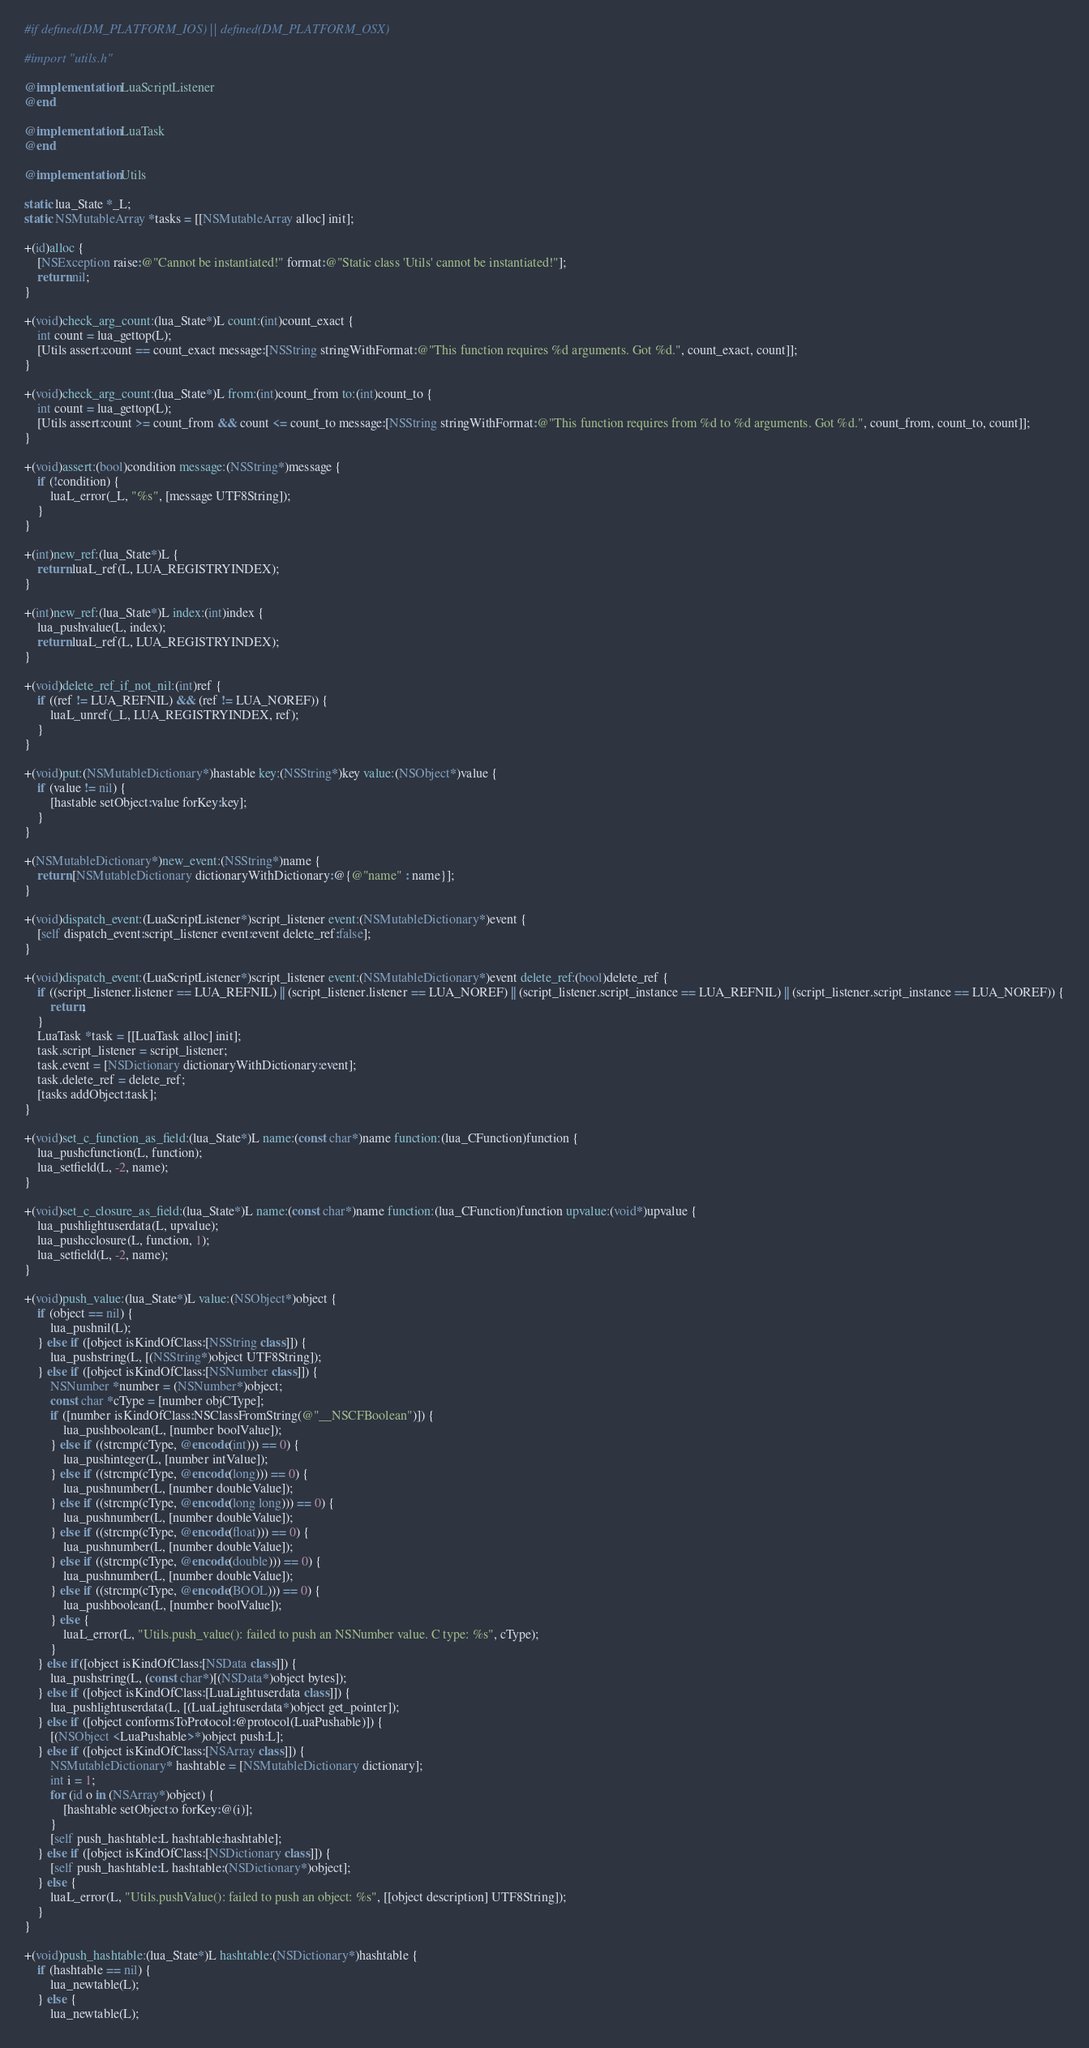<code> <loc_0><loc_0><loc_500><loc_500><_ObjectiveC_>#if defined(DM_PLATFORM_IOS) || defined(DM_PLATFORM_OSX)

#import "utils.h"

@implementation LuaScriptListener
@end

@implementation LuaTask
@end

@implementation Utils

static lua_State *_L;
static NSMutableArray *tasks = [[NSMutableArray alloc] init];

+(id)alloc {
	[NSException raise:@"Cannot be instantiated!" format:@"Static class 'Utils' cannot be instantiated!"];
	return nil;
}

+(void)check_arg_count:(lua_State*)L count:(int)count_exact {
	int count = lua_gettop(L);
	[Utils assert:count == count_exact message:[NSString stringWithFormat:@"This function requires %d arguments. Got %d.", count_exact, count]];
}

+(void)check_arg_count:(lua_State*)L from:(int)count_from to:(int)count_to {
	int count = lua_gettop(L);
	[Utils assert:count >= count_from && count <= count_to message:[NSString stringWithFormat:@"This function requires from %d to %d arguments. Got %d.", count_from, count_to, count]];
}

+(void)assert:(bool)condition message:(NSString*)message {
	if (!condition) {
		luaL_error(_L, "%s", [message UTF8String]);
	}
}

+(int)new_ref:(lua_State*)L {
	return luaL_ref(L, LUA_REGISTRYINDEX);
}

+(int)new_ref:(lua_State*)L index:(int)index {
	lua_pushvalue(L, index);
	return luaL_ref(L, LUA_REGISTRYINDEX);
}

+(void)delete_ref_if_not_nil:(int)ref {
	if ((ref != LUA_REFNIL) && (ref != LUA_NOREF)) {
		luaL_unref(_L, LUA_REGISTRYINDEX, ref);
	}
}

+(void)put:(NSMutableDictionary*)hastable key:(NSString*)key value:(NSObject*)value {
	if (value != nil) {
		[hastable setObject:value forKey:key];
	}
}

+(NSMutableDictionary*)new_event:(NSString*)name {
	return [NSMutableDictionary dictionaryWithDictionary:@{@"name" : name}];
}

+(void)dispatch_event:(LuaScriptListener*)script_listener event:(NSMutableDictionary*)event {
	[self dispatch_event:script_listener event:event delete_ref:false];
}

+(void)dispatch_event:(LuaScriptListener*)script_listener event:(NSMutableDictionary*)event delete_ref:(bool)delete_ref {
	if ((script_listener.listener == LUA_REFNIL) || (script_listener.listener == LUA_NOREF) || (script_listener.script_instance == LUA_REFNIL) || (script_listener.script_instance == LUA_NOREF)) {
		return;
	}
	LuaTask *task = [[LuaTask alloc] init];
	task.script_listener = script_listener;
	task.event = [NSDictionary dictionaryWithDictionary:event];
	task.delete_ref = delete_ref;
	[tasks addObject:task];
}

+(void)set_c_function_as_field:(lua_State*)L name:(const char*)name function:(lua_CFunction)function {
	lua_pushcfunction(L, function);
	lua_setfield(L, -2, name);
}

+(void)set_c_closure_as_field:(lua_State*)L name:(const char*)name function:(lua_CFunction)function upvalue:(void*)upvalue {
	lua_pushlightuserdata(L, upvalue);
	lua_pushcclosure(L, function, 1);
	lua_setfield(L, -2, name);
}

+(void)push_value:(lua_State*)L value:(NSObject*)object {
	if (object == nil) {
		lua_pushnil(L);
	} else if ([object isKindOfClass:[NSString class]]) {
		lua_pushstring(L, [(NSString*)object UTF8String]);
	} else if ([object isKindOfClass:[NSNumber class]]) {
		NSNumber *number = (NSNumber*)object;
		const char *cType = [number objCType];
		if ([number isKindOfClass:NSClassFromString(@"__NSCFBoolean")]) {
			lua_pushboolean(L, [number boolValue]);
		} else if ((strcmp(cType, @encode(int))) == 0) {
			lua_pushinteger(L, [number intValue]);
		} else if ((strcmp(cType, @encode(long))) == 0) {
			lua_pushnumber(L, [number doubleValue]);
		} else if ((strcmp(cType, @encode(long long))) == 0) {
			lua_pushnumber(L, [number doubleValue]);
		} else if ((strcmp(cType, @encode(float))) == 0) {
			lua_pushnumber(L, [number doubleValue]);
		} else if ((strcmp(cType, @encode(double))) == 0) {
			lua_pushnumber(L, [number doubleValue]);
		} else if ((strcmp(cType, @encode(BOOL))) == 0) {
			lua_pushboolean(L, [number boolValue]);
		} else {
			luaL_error(L, "Utils.push_value(): failed to push an NSNumber value. C type: %s", cType);
		}
	} else if([object isKindOfClass:[NSData class]]) {
		lua_pushstring(L, (const char*)[(NSData*)object bytes]);
	} else if ([object isKindOfClass:[LuaLightuserdata class]]) {
		lua_pushlightuserdata(L, [(LuaLightuserdata*)object get_pointer]);
	} else if ([object conformsToProtocol:@protocol(LuaPushable)]) {
		[(NSObject <LuaPushable>*)object push:L];
	} else if ([object isKindOfClass:[NSArray class]]) {
		NSMutableDictionary* hashtable = [NSMutableDictionary dictionary];
		int i = 1;
		for (id o in (NSArray*)object) {
			[hashtable setObject:o forKey:@(i)];
		}
		[self push_hashtable:L hashtable:hashtable];
	} else if ([object isKindOfClass:[NSDictionary class]]) {
		[self push_hashtable:L hashtable:(NSDictionary*)object];
	} else {
		luaL_error(L, "Utils.pushValue(): failed to push an object: %s", [[object description] UTF8String]);
	}
}

+(void)push_hashtable:(lua_State*)L hashtable:(NSDictionary*)hashtable {
	if (hashtable == nil) {
		lua_newtable(L);
	} else {
		lua_newtable(L);</code> 